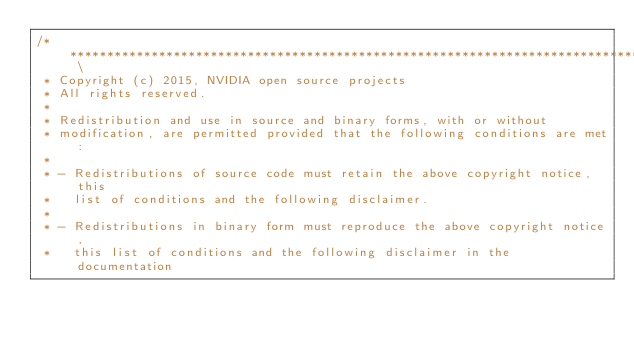Convert code to text. <code><loc_0><loc_0><loc_500><loc_500><_Cuda_>/*********************************************************************************** \
 * Copyright (c) 2015, NVIDIA open source projects
 * All rights reserved.
 * 
 * Redistribution and use in source and binary forms, with or without
 * modification, are permitted provided that the following conditions are met:
 * 
 * - Redistributions of source code must retain the above copyright notice, this
 *   list of conditions and the following disclaimer.
 * 
 * - Redistributions in binary form must reproduce the above copyright notice,
 *   this list of conditions and the following disclaimer in the documentation</code> 